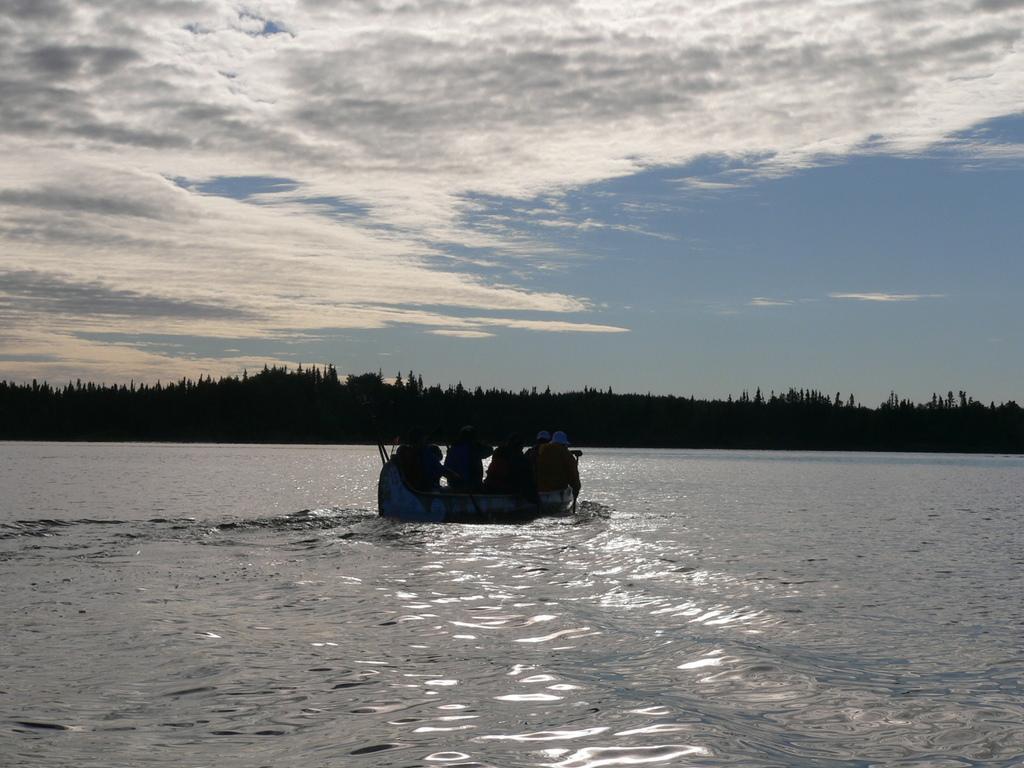Could you give a brief overview of what you see in this image? In this image I can see the boat on the water. There are few people sitting in the boat. In the background I can see many trees, clouds and the sky. 